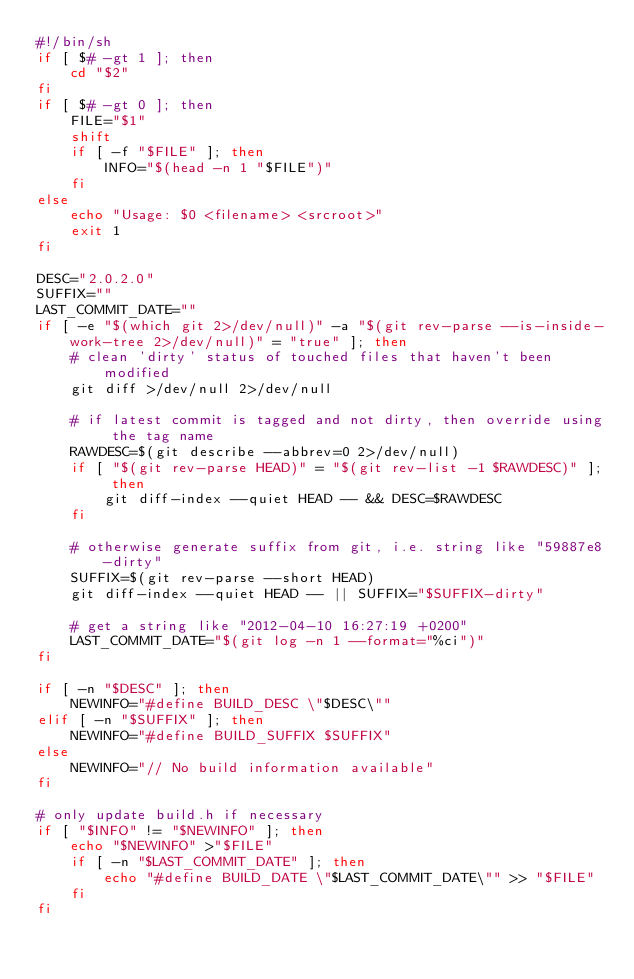Convert code to text. <code><loc_0><loc_0><loc_500><loc_500><_Bash_>#!/bin/sh
if [ $# -gt 1 ]; then
    cd "$2"
fi
if [ $# -gt 0 ]; then
    FILE="$1"
    shift
    if [ -f "$FILE" ]; then
        INFO="$(head -n 1 "$FILE")"
    fi
else
    echo "Usage: $0 <filename> <srcroot>"
    exit 1
fi

DESC="2.0.2.0"
SUFFIX=""
LAST_COMMIT_DATE=""
if [ -e "$(which git 2>/dev/null)" -a "$(git rev-parse --is-inside-work-tree 2>/dev/null)" = "true" ]; then
    # clean 'dirty' status of touched files that haven't been modified
    git diff >/dev/null 2>/dev/null

    # if latest commit is tagged and not dirty, then override using the tag name
    RAWDESC=$(git describe --abbrev=0 2>/dev/null)
    if [ "$(git rev-parse HEAD)" = "$(git rev-list -1 $RAWDESC)" ]; then
        git diff-index --quiet HEAD -- && DESC=$RAWDESC
    fi

    # otherwise generate suffix from git, i.e. string like "59887e8-dirty"
    SUFFIX=$(git rev-parse --short HEAD)
    git diff-index --quiet HEAD -- || SUFFIX="$SUFFIX-dirty"

    # get a string like "2012-04-10 16:27:19 +0200"
    LAST_COMMIT_DATE="$(git log -n 1 --format="%ci")"
fi

if [ -n "$DESC" ]; then
    NEWINFO="#define BUILD_DESC \"$DESC\""
elif [ -n "$SUFFIX" ]; then
    NEWINFO="#define BUILD_SUFFIX $SUFFIX"
else
    NEWINFO="// No build information available"
fi

# only update build.h if necessary
if [ "$INFO" != "$NEWINFO" ]; then
    echo "$NEWINFO" >"$FILE"
    if [ -n "$LAST_COMMIT_DATE" ]; then
        echo "#define BUILD_DATE \"$LAST_COMMIT_DATE\"" >> "$FILE"
    fi
fi
</code> 